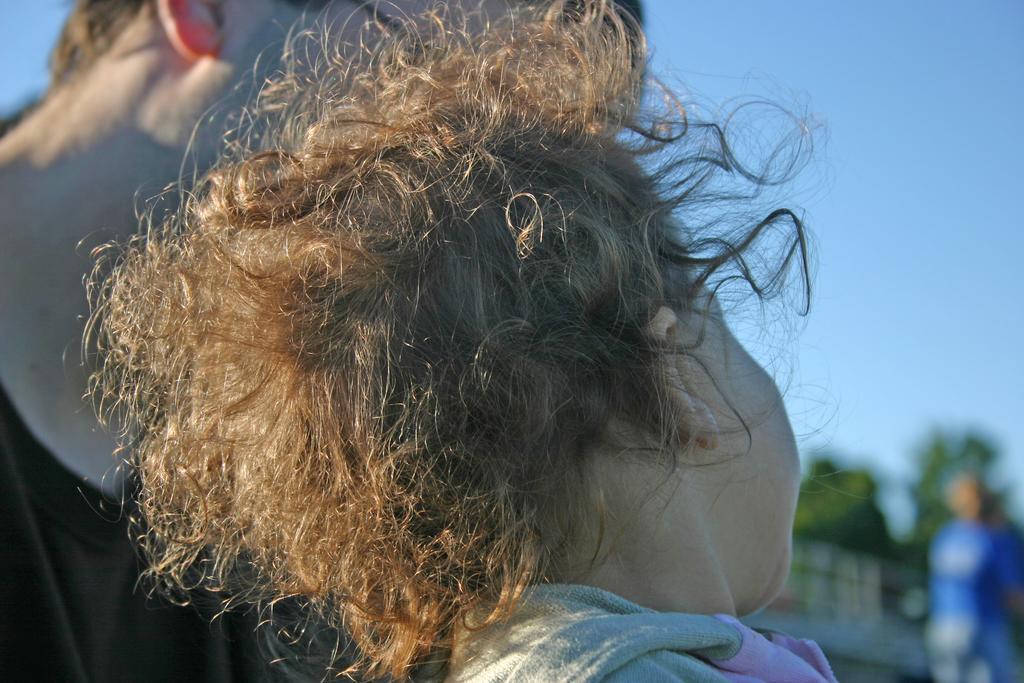In one or two sentences, can you explain what this image depicts? There are persons and we can see sky. Background it is blur. 